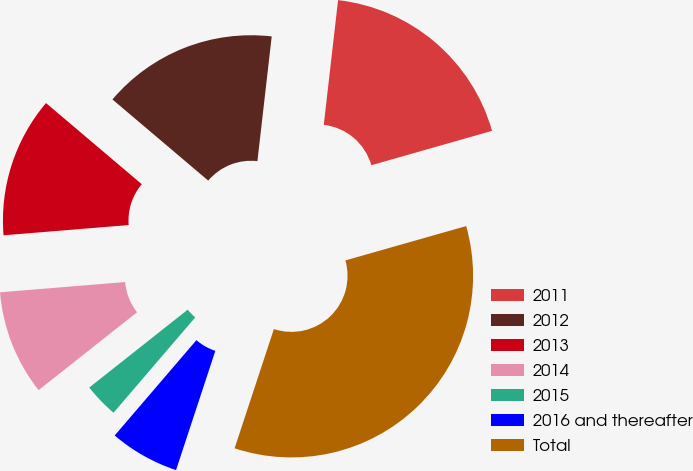Convert chart. <chart><loc_0><loc_0><loc_500><loc_500><pie_chart><fcel>2011<fcel>2012<fcel>2013<fcel>2014<fcel>2015<fcel>2016 and thereafter<fcel>Total<nl><fcel>18.77%<fcel>15.63%<fcel>12.49%<fcel>9.35%<fcel>3.07%<fcel>6.21%<fcel>34.48%<nl></chart> 